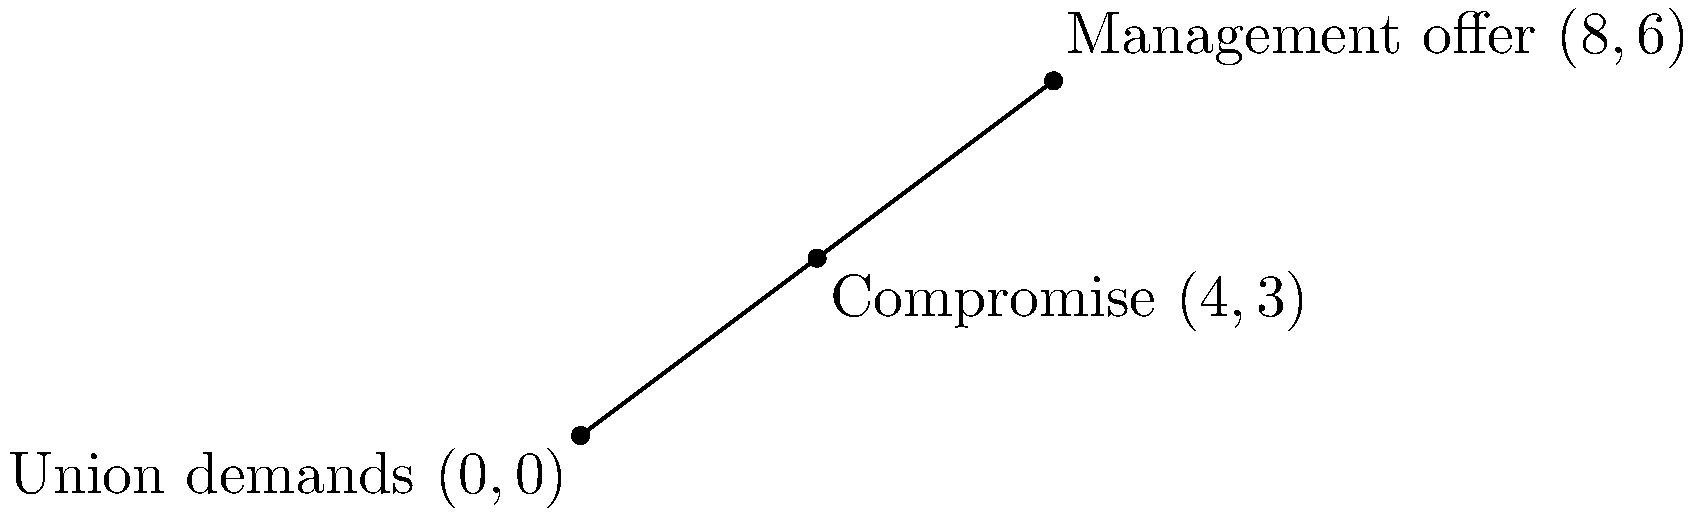In negotiations between the union and management, the union's initial demand is represented by the point $(0,0)$, while management's initial offer is at $(8,6)$. If a compromise is to be reached at the midpoint of the line segment connecting these two points, what are the coordinates of this compromise point? To find the midpoint of a line segment, we can use the midpoint formula:

$$ M_x = \frac{x_1 + x_2}{2}, \quad M_y = \frac{y_1 + y_2}{2} $$

Where $(x_1, y_1)$ is the first point and $(x_2, y_2)$ is the second point.

1. Identify the coordinates:
   - Union demands: $(x_1, y_1) = (0, 0)$
   - Management offer: $(x_2, y_2) = (8, 6)$

2. Calculate the x-coordinate of the midpoint:
   $$ M_x = \frac{x_1 + x_2}{2} = \frac{0 + 8}{2} = \frac{8}{2} = 4 $$

3. Calculate the y-coordinate of the midpoint:
   $$ M_y = \frac{y_1 + y_2}{2} = \frac{0 + 6}{2} = \frac{6}{2} = 3 $$

4. Combine the results:
   The midpoint (compromise) is at $(4, 3)$.
Answer: $(4, 3)$ 